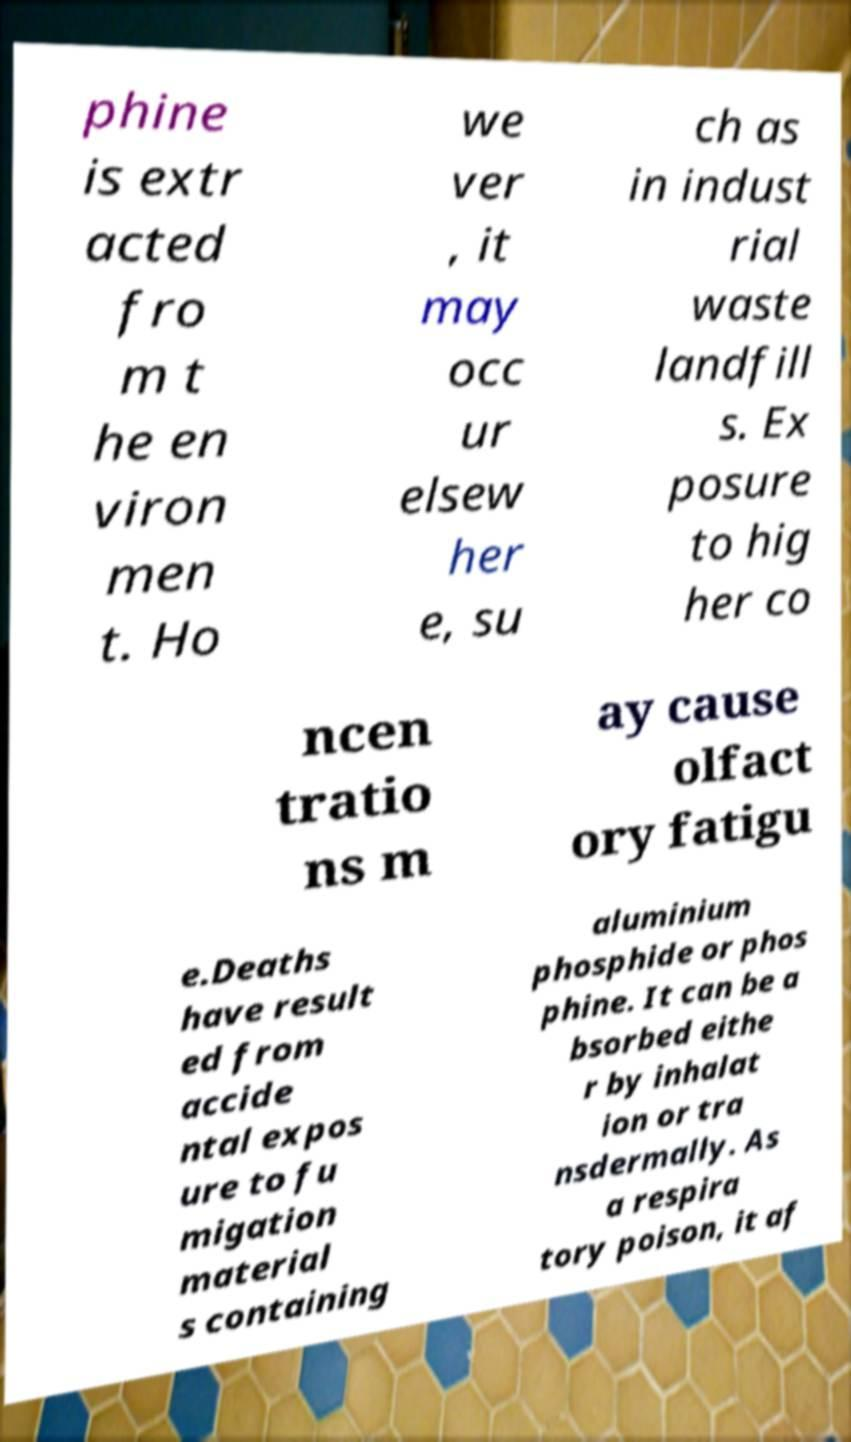I need the written content from this picture converted into text. Can you do that? phine is extr acted fro m t he en viron men t. Ho we ver , it may occ ur elsew her e, su ch as in indust rial waste landfill s. Ex posure to hig her co ncen tratio ns m ay cause olfact ory fatigu e.Deaths have result ed from accide ntal expos ure to fu migation material s containing aluminium phosphide or phos phine. It can be a bsorbed eithe r by inhalat ion or tra nsdermally. As a respira tory poison, it af 